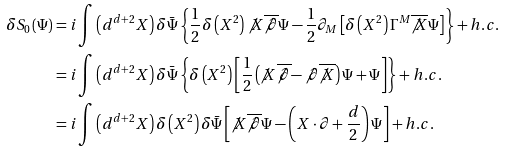<formula> <loc_0><loc_0><loc_500><loc_500>\delta S _ { 0 } \left ( \Psi \right ) & = i \int \left ( d ^ { d + 2 } X \right ) \delta \bar { \Psi } \left \{ \frac { 1 } { 2 } \delta \left ( X ^ { 2 } \right ) \not X \overline { \not \partial } \Psi - \frac { 1 } { 2 } \partial _ { M } \left [ \delta \left ( X ^ { 2 } \right ) \Gamma ^ { M } \overline { \not X } \Psi \right ] \right \} + h . c . \\ & = i \int \left ( d ^ { d + 2 } X \right ) \delta \bar { \Psi } \left \{ \delta \left ( X ^ { 2 } \right ) \left [ \frac { 1 } { 2 } \left ( \not X \overline { \not \partial } - \not \partial \overline { \not X } \right ) \Psi + \Psi \right ] \right \} + h . c . \\ & = i \int \left ( d ^ { d + 2 } X \right ) \delta \left ( X ^ { 2 } \right ) \delta \bar { \Psi } \left [ \not X \overline { \not \partial } \Psi - \left ( X \cdot \partial + \frac { d } { 2 } \right ) \Psi \right ] + h . c .</formula> 